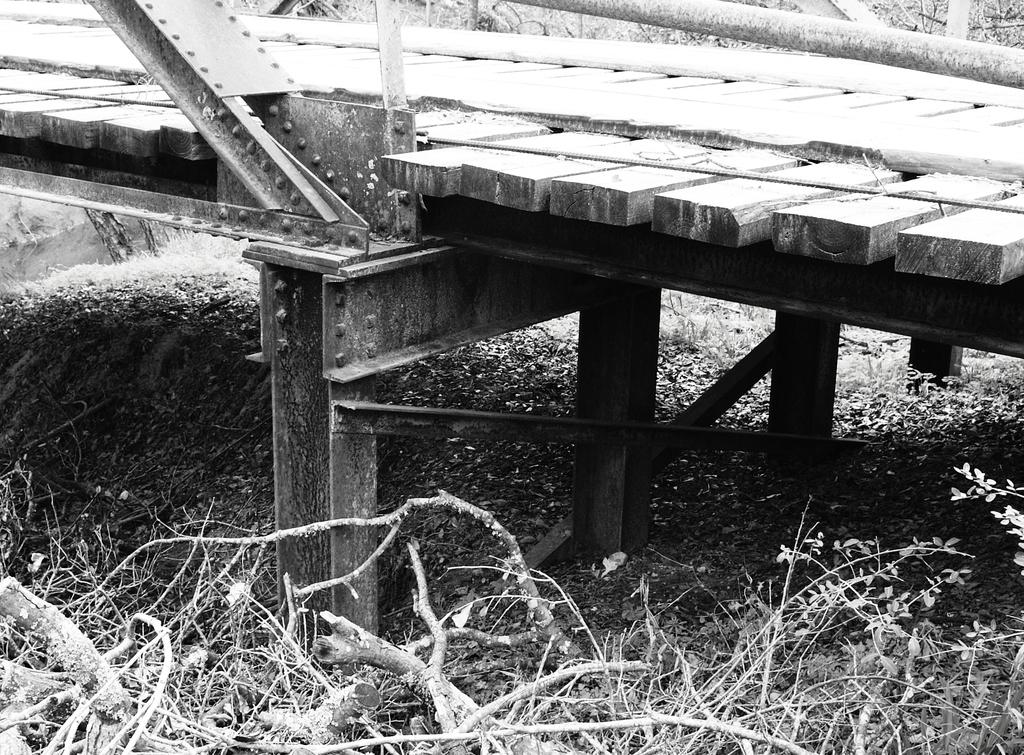What is the color scheme of the image? The image is black and white. What structure can be seen in the image? There is a bridge in the image. What materials were used to build the bridge? The bridge is built with wood and iron bars. What can be seen at the bottom of the image? Branches are visible at the bottom of the image. What type of seed is being planted by the animal in the image? There is no animal or seed present in the image; it features a black and white image of a bridge. Can you describe the driving conditions in the image? There is no driving or vehicle present in the image; it features a black and white image of a bridge. 